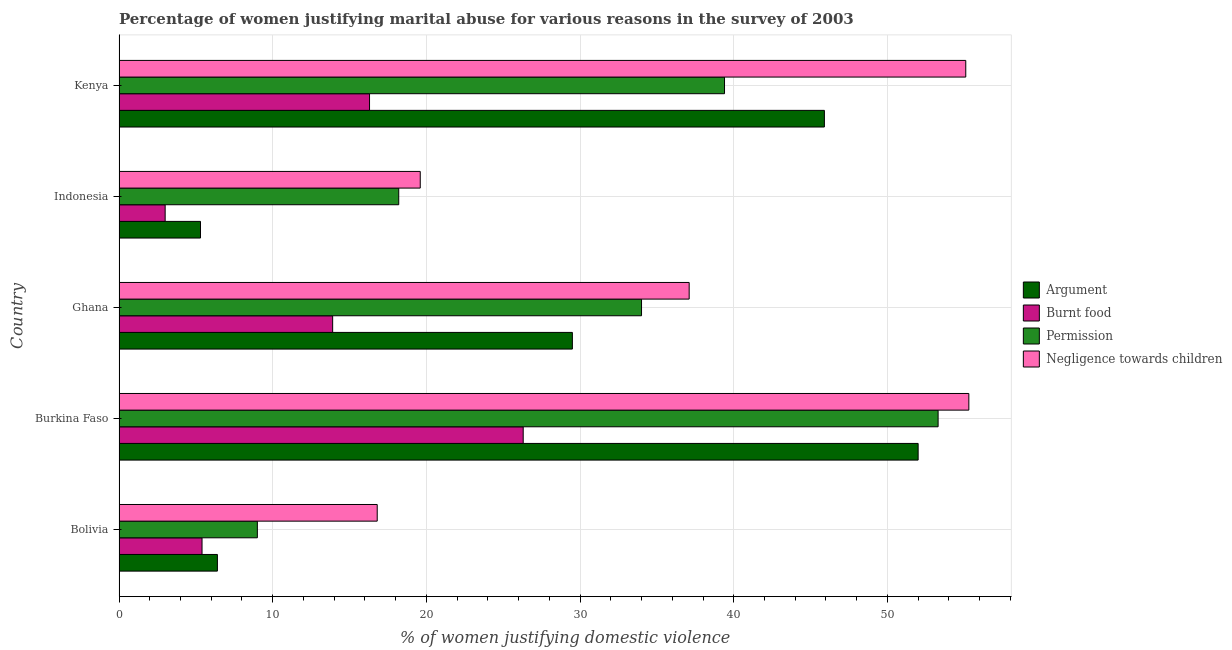How many different coloured bars are there?
Offer a terse response. 4. Are the number of bars on each tick of the Y-axis equal?
Give a very brief answer. Yes. What is the label of the 2nd group of bars from the top?
Offer a terse response. Indonesia. In how many cases, is the number of bars for a given country not equal to the number of legend labels?
Provide a short and direct response. 0. Across all countries, what is the maximum percentage of women justifying abuse for showing negligence towards children?
Offer a terse response. 55.3. Across all countries, what is the minimum percentage of women justifying abuse for burning food?
Your answer should be very brief. 3. In which country was the percentage of women justifying abuse for showing negligence towards children maximum?
Your answer should be compact. Burkina Faso. In which country was the percentage of women justifying abuse for burning food minimum?
Keep it short and to the point. Indonesia. What is the total percentage of women justifying abuse for showing negligence towards children in the graph?
Offer a very short reply. 183.9. What is the difference between the percentage of women justifying abuse for showing negligence towards children in Bolivia and the percentage of women justifying abuse in the case of an argument in Burkina Faso?
Offer a very short reply. -35.2. What is the average percentage of women justifying abuse for showing negligence towards children per country?
Your answer should be compact. 36.78. Is the percentage of women justifying abuse in the case of an argument in Burkina Faso less than that in Indonesia?
Your answer should be compact. No. What is the difference between the highest and the lowest percentage of women justifying abuse for showing negligence towards children?
Your answer should be very brief. 38.5. Is the sum of the percentage of women justifying abuse for showing negligence towards children in Burkina Faso and Indonesia greater than the maximum percentage of women justifying abuse in the case of an argument across all countries?
Keep it short and to the point. Yes. Is it the case that in every country, the sum of the percentage of women justifying abuse for going without permission and percentage of women justifying abuse in the case of an argument is greater than the sum of percentage of women justifying abuse for burning food and percentage of women justifying abuse for showing negligence towards children?
Keep it short and to the point. No. What does the 1st bar from the top in Indonesia represents?
Your answer should be very brief. Negligence towards children. What does the 1st bar from the bottom in Burkina Faso represents?
Keep it short and to the point. Argument. Is it the case that in every country, the sum of the percentage of women justifying abuse in the case of an argument and percentage of women justifying abuse for burning food is greater than the percentage of women justifying abuse for going without permission?
Your answer should be very brief. No. How many countries are there in the graph?
Provide a succinct answer. 5. Are the values on the major ticks of X-axis written in scientific E-notation?
Make the answer very short. No. Does the graph contain grids?
Offer a terse response. Yes. Where does the legend appear in the graph?
Offer a very short reply. Center right. How many legend labels are there?
Keep it short and to the point. 4. How are the legend labels stacked?
Offer a very short reply. Vertical. What is the title of the graph?
Offer a very short reply. Percentage of women justifying marital abuse for various reasons in the survey of 2003. What is the label or title of the X-axis?
Your response must be concise. % of women justifying domestic violence. What is the % of women justifying domestic violence of Burnt food in Bolivia?
Your response must be concise. 5.4. What is the % of women justifying domestic violence of Burnt food in Burkina Faso?
Keep it short and to the point. 26.3. What is the % of women justifying domestic violence in Permission in Burkina Faso?
Provide a short and direct response. 53.3. What is the % of women justifying domestic violence in Negligence towards children in Burkina Faso?
Provide a short and direct response. 55.3. What is the % of women justifying domestic violence in Argument in Ghana?
Ensure brevity in your answer.  29.5. What is the % of women justifying domestic violence of Negligence towards children in Ghana?
Your response must be concise. 37.1. What is the % of women justifying domestic violence of Burnt food in Indonesia?
Provide a short and direct response. 3. What is the % of women justifying domestic violence of Negligence towards children in Indonesia?
Offer a very short reply. 19.6. What is the % of women justifying domestic violence in Argument in Kenya?
Your answer should be very brief. 45.9. What is the % of women justifying domestic violence of Burnt food in Kenya?
Make the answer very short. 16.3. What is the % of women justifying domestic violence in Permission in Kenya?
Your answer should be very brief. 39.4. What is the % of women justifying domestic violence in Negligence towards children in Kenya?
Your answer should be very brief. 55.1. Across all countries, what is the maximum % of women justifying domestic violence in Argument?
Your answer should be compact. 52. Across all countries, what is the maximum % of women justifying domestic violence in Burnt food?
Provide a succinct answer. 26.3. Across all countries, what is the maximum % of women justifying domestic violence in Permission?
Your answer should be compact. 53.3. Across all countries, what is the maximum % of women justifying domestic violence in Negligence towards children?
Provide a succinct answer. 55.3. Across all countries, what is the minimum % of women justifying domestic violence in Burnt food?
Your answer should be very brief. 3. What is the total % of women justifying domestic violence in Argument in the graph?
Provide a short and direct response. 139.1. What is the total % of women justifying domestic violence in Burnt food in the graph?
Offer a terse response. 64.9. What is the total % of women justifying domestic violence of Permission in the graph?
Offer a terse response. 153.9. What is the total % of women justifying domestic violence in Negligence towards children in the graph?
Make the answer very short. 183.9. What is the difference between the % of women justifying domestic violence in Argument in Bolivia and that in Burkina Faso?
Your answer should be compact. -45.6. What is the difference between the % of women justifying domestic violence of Burnt food in Bolivia and that in Burkina Faso?
Keep it short and to the point. -20.9. What is the difference between the % of women justifying domestic violence in Permission in Bolivia and that in Burkina Faso?
Make the answer very short. -44.3. What is the difference between the % of women justifying domestic violence of Negligence towards children in Bolivia and that in Burkina Faso?
Offer a very short reply. -38.5. What is the difference between the % of women justifying domestic violence in Argument in Bolivia and that in Ghana?
Make the answer very short. -23.1. What is the difference between the % of women justifying domestic violence of Burnt food in Bolivia and that in Ghana?
Offer a very short reply. -8.5. What is the difference between the % of women justifying domestic violence in Negligence towards children in Bolivia and that in Ghana?
Ensure brevity in your answer.  -20.3. What is the difference between the % of women justifying domestic violence in Argument in Bolivia and that in Indonesia?
Provide a short and direct response. 1.1. What is the difference between the % of women justifying domestic violence in Argument in Bolivia and that in Kenya?
Offer a terse response. -39.5. What is the difference between the % of women justifying domestic violence in Burnt food in Bolivia and that in Kenya?
Your answer should be very brief. -10.9. What is the difference between the % of women justifying domestic violence in Permission in Bolivia and that in Kenya?
Provide a succinct answer. -30.4. What is the difference between the % of women justifying domestic violence of Negligence towards children in Bolivia and that in Kenya?
Give a very brief answer. -38.3. What is the difference between the % of women justifying domestic violence in Argument in Burkina Faso and that in Ghana?
Make the answer very short. 22.5. What is the difference between the % of women justifying domestic violence of Permission in Burkina Faso and that in Ghana?
Your answer should be very brief. 19.3. What is the difference between the % of women justifying domestic violence of Negligence towards children in Burkina Faso and that in Ghana?
Keep it short and to the point. 18.2. What is the difference between the % of women justifying domestic violence of Argument in Burkina Faso and that in Indonesia?
Keep it short and to the point. 46.7. What is the difference between the % of women justifying domestic violence of Burnt food in Burkina Faso and that in Indonesia?
Make the answer very short. 23.3. What is the difference between the % of women justifying domestic violence in Permission in Burkina Faso and that in Indonesia?
Offer a very short reply. 35.1. What is the difference between the % of women justifying domestic violence of Negligence towards children in Burkina Faso and that in Indonesia?
Provide a succinct answer. 35.7. What is the difference between the % of women justifying domestic violence in Burnt food in Burkina Faso and that in Kenya?
Keep it short and to the point. 10. What is the difference between the % of women justifying domestic violence in Negligence towards children in Burkina Faso and that in Kenya?
Give a very brief answer. 0.2. What is the difference between the % of women justifying domestic violence of Argument in Ghana and that in Indonesia?
Your answer should be very brief. 24.2. What is the difference between the % of women justifying domestic violence of Burnt food in Ghana and that in Indonesia?
Ensure brevity in your answer.  10.9. What is the difference between the % of women justifying domestic violence in Argument in Ghana and that in Kenya?
Your answer should be compact. -16.4. What is the difference between the % of women justifying domestic violence of Negligence towards children in Ghana and that in Kenya?
Your response must be concise. -18. What is the difference between the % of women justifying domestic violence in Argument in Indonesia and that in Kenya?
Your answer should be compact. -40.6. What is the difference between the % of women justifying domestic violence in Burnt food in Indonesia and that in Kenya?
Ensure brevity in your answer.  -13.3. What is the difference between the % of women justifying domestic violence of Permission in Indonesia and that in Kenya?
Your answer should be very brief. -21.2. What is the difference between the % of women justifying domestic violence in Negligence towards children in Indonesia and that in Kenya?
Provide a short and direct response. -35.5. What is the difference between the % of women justifying domestic violence of Argument in Bolivia and the % of women justifying domestic violence of Burnt food in Burkina Faso?
Your response must be concise. -19.9. What is the difference between the % of women justifying domestic violence in Argument in Bolivia and the % of women justifying domestic violence in Permission in Burkina Faso?
Your answer should be compact. -46.9. What is the difference between the % of women justifying domestic violence in Argument in Bolivia and the % of women justifying domestic violence in Negligence towards children in Burkina Faso?
Offer a very short reply. -48.9. What is the difference between the % of women justifying domestic violence of Burnt food in Bolivia and the % of women justifying domestic violence of Permission in Burkina Faso?
Provide a short and direct response. -47.9. What is the difference between the % of women justifying domestic violence in Burnt food in Bolivia and the % of women justifying domestic violence in Negligence towards children in Burkina Faso?
Make the answer very short. -49.9. What is the difference between the % of women justifying domestic violence in Permission in Bolivia and the % of women justifying domestic violence in Negligence towards children in Burkina Faso?
Your response must be concise. -46.3. What is the difference between the % of women justifying domestic violence of Argument in Bolivia and the % of women justifying domestic violence of Permission in Ghana?
Give a very brief answer. -27.6. What is the difference between the % of women justifying domestic violence in Argument in Bolivia and the % of women justifying domestic violence in Negligence towards children in Ghana?
Offer a terse response. -30.7. What is the difference between the % of women justifying domestic violence in Burnt food in Bolivia and the % of women justifying domestic violence in Permission in Ghana?
Your response must be concise. -28.6. What is the difference between the % of women justifying domestic violence in Burnt food in Bolivia and the % of women justifying domestic violence in Negligence towards children in Ghana?
Offer a very short reply. -31.7. What is the difference between the % of women justifying domestic violence in Permission in Bolivia and the % of women justifying domestic violence in Negligence towards children in Ghana?
Offer a very short reply. -28.1. What is the difference between the % of women justifying domestic violence of Argument in Bolivia and the % of women justifying domestic violence of Negligence towards children in Indonesia?
Your answer should be very brief. -13.2. What is the difference between the % of women justifying domestic violence in Burnt food in Bolivia and the % of women justifying domestic violence in Permission in Indonesia?
Offer a terse response. -12.8. What is the difference between the % of women justifying domestic violence in Burnt food in Bolivia and the % of women justifying domestic violence in Negligence towards children in Indonesia?
Ensure brevity in your answer.  -14.2. What is the difference between the % of women justifying domestic violence of Permission in Bolivia and the % of women justifying domestic violence of Negligence towards children in Indonesia?
Keep it short and to the point. -10.6. What is the difference between the % of women justifying domestic violence in Argument in Bolivia and the % of women justifying domestic violence in Burnt food in Kenya?
Your response must be concise. -9.9. What is the difference between the % of women justifying domestic violence of Argument in Bolivia and the % of women justifying domestic violence of Permission in Kenya?
Give a very brief answer. -33. What is the difference between the % of women justifying domestic violence in Argument in Bolivia and the % of women justifying domestic violence in Negligence towards children in Kenya?
Offer a terse response. -48.7. What is the difference between the % of women justifying domestic violence in Burnt food in Bolivia and the % of women justifying domestic violence in Permission in Kenya?
Keep it short and to the point. -34. What is the difference between the % of women justifying domestic violence in Burnt food in Bolivia and the % of women justifying domestic violence in Negligence towards children in Kenya?
Provide a short and direct response. -49.7. What is the difference between the % of women justifying domestic violence in Permission in Bolivia and the % of women justifying domestic violence in Negligence towards children in Kenya?
Offer a terse response. -46.1. What is the difference between the % of women justifying domestic violence in Argument in Burkina Faso and the % of women justifying domestic violence in Burnt food in Ghana?
Give a very brief answer. 38.1. What is the difference between the % of women justifying domestic violence of Argument in Burkina Faso and the % of women justifying domestic violence of Negligence towards children in Ghana?
Offer a very short reply. 14.9. What is the difference between the % of women justifying domestic violence in Burnt food in Burkina Faso and the % of women justifying domestic violence in Permission in Ghana?
Your response must be concise. -7.7. What is the difference between the % of women justifying domestic violence of Permission in Burkina Faso and the % of women justifying domestic violence of Negligence towards children in Ghana?
Keep it short and to the point. 16.2. What is the difference between the % of women justifying domestic violence of Argument in Burkina Faso and the % of women justifying domestic violence of Burnt food in Indonesia?
Provide a short and direct response. 49. What is the difference between the % of women justifying domestic violence in Argument in Burkina Faso and the % of women justifying domestic violence in Permission in Indonesia?
Offer a terse response. 33.8. What is the difference between the % of women justifying domestic violence of Argument in Burkina Faso and the % of women justifying domestic violence of Negligence towards children in Indonesia?
Offer a very short reply. 32.4. What is the difference between the % of women justifying domestic violence in Burnt food in Burkina Faso and the % of women justifying domestic violence in Negligence towards children in Indonesia?
Offer a terse response. 6.7. What is the difference between the % of women justifying domestic violence of Permission in Burkina Faso and the % of women justifying domestic violence of Negligence towards children in Indonesia?
Offer a terse response. 33.7. What is the difference between the % of women justifying domestic violence of Argument in Burkina Faso and the % of women justifying domestic violence of Burnt food in Kenya?
Provide a succinct answer. 35.7. What is the difference between the % of women justifying domestic violence in Argument in Burkina Faso and the % of women justifying domestic violence in Permission in Kenya?
Give a very brief answer. 12.6. What is the difference between the % of women justifying domestic violence of Burnt food in Burkina Faso and the % of women justifying domestic violence of Permission in Kenya?
Provide a succinct answer. -13.1. What is the difference between the % of women justifying domestic violence in Burnt food in Burkina Faso and the % of women justifying domestic violence in Negligence towards children in Kenya?
Ensure brevity in your answer.  -28.8. What is the difference between the % of women justifying domestic violence in Permission in Burkina Faso and the % of women justifying domestic violence in Negligence towards children in Kenya?
Ensure brevity in your answer.  -1.8. What is the difference between the % of women justifying domestic violence in Argument in Ghana and the % of women justifying domestic violence in Burnt food in Indonesia?
Your response must be concise. 26.5. What is the difference between the % of women justifying domestic violence in Argument in Ghana and the % of women justifying domestic violence in Permission in Indonesia?
Offer a very short reply. 11.3. What is the difference between the % of women justifying domestic violence in Burnt food in Ghana and the % of women justifying domestic violence in Permission in Indonesia?
Ensure brevity in your answer.  -4.3. What is the difference between the % of women justifying domestic violence of Burnt food in Ghana and the % of women justifying domestic violence of Negligence towards children in Indonesia?
Offer a very short reply. -5.7. What is the difference between the % of women justifying domestic violence in Argument in Ghana and the % of women justifying domestic violence in Burnt food in Kenya?
Keep it short and to the point. 13.2. What is the difference between the % of women justifying domestic violence in Argument in Ghana and the % of women justifying domestic violence in Negligence towards children in Kenya?
Make the answer very short. -25.6. What is the difference between the % of women justifying domestic violence of Burnt food in Ghana and the % of women justifying domestic violence of Permission in Kenya?
Give a very brief answer. -25.5. What is the difference between the % of women justifying domestic violence of Burnt food in Ghana and the % of women justifying domestic violence of Negligence towards children in Kenya?
Give a very brief answer. -41.2. What is the difference between the % of women justifying domestic violence of Permission in Ghana and the % of women justifying domestic violence of Negligence towards children in Kenya?
Your answer should be compact. -21.1. What is the difference between the % of women justifying domestic violence of Argument in Indonesia and the % of women justifying domestic violence of Permission in Kenya?
Your answer should be compact. -34.1. What is the difference between the % of women justifying domestic violence of Argument in Indonesia and the % of women justifying domestic violence of Negligence towards children in Kenya?
Offer a terse response. -49.8. What is the difference between the % of women justifying domestic violence of Burnt food in Indonesia and the % of women justifying domestic violence of Permission in Kenya?
Make the answer very short. -36.4. What is the difference between the % of women justifying domestic violence of Burnt food in Indonesia and the % of women justifying domestic violence of Negligence towards children in Kenya?
Offer a very short reply. -52.1. What is the difference between the % of women justifying domestic violence of Permission in Indonesia and the % of women justifying domestic violence of Negligence towards children in Kenya?
Provide a succinct answer. -36.9. What is the average % of women justifying domestic violence in Argument per country?
Your response must be concise. 27.82. What is the average % of women justifying domestic violence of Burnt food per country?
Make the answer very short. 12.98. What is the average % of women justifying domestic violence of Permission per country?
Ensure brevity in your answer.  30.78. What is the average % of women justifying domestic violence in Negligence towards children per country?
Offer a very short reply. 36.78. What is the difference between the % of women justifying domestic violence in Argument and % of women justifying domestic violence in Burnt food in Bolivia?
Your answer should be very brief. 1. What is the difference between the % of women justifying domestic violence in Argument and % of women justifying domestic violence in Permission in Bolivia?
Offer a very short reply. -2.6. What is the difference between the % of women justifying domestic violence of Argument and % of women justifying domestic violence of Negligence towards children in Bolivia?
Make the answer very short. -10.4. What is the difference between the % of women justifying domestic violence in Burnt food and % of women justifying domestic violence in Negligence towards children in Bolivia?
Provide a short and direct response. -11.4. What is the difference between the % of women justifying domestic violence of Argument and % of women justifying domestic violence of Burnt food in Burkina Faso?
Your answer should be compact. 25.7. What is the difference between the % of women justifying domestic violence of Burnt food and % of women justifying domestic violence of Permission in Burkina Faso?
Your answer should be compact. -27. What is the difference between the % of women justifying domestic violence in Argument and % of women justifying domestic violence in Permission in Ghana?
Your answer should be very brief. -4.5. What is the difference between the % of women justifying domestic violence of Burnt food and % of women justifying domestic violence of Permission in Ghana?
Ensure brevity in your answer.  -20.1. What is the difference between the % of women justifying domestic violence in Burnt food and % of women justifying domestic violence in Negligence towards children in Ghana?
Your answer should be very brief. -23.2. What is the difference between the % of women justifying domestic violence of Argument and % of women justifying domestic violence of Permission in Indonesia?
Provide a succinct answer. -12.9. What is the difference between the % of women justifying domestic violence in Argument and % of women justifying domestic violence in Negligence towards children in Indonesia?
Provide a short and direct response. -14.3. What is the difference between the % of women justifying domestic violence in Burnt food and % of women justifying domestic violence in Permission in Indonesia?
Offer a terse response. -15.2. What is the difference between the % of women justifying domestic violence in Burnt food and % of women justifying domestic violence in Negligence towards children in Indonesia?
Your response must be concise. -16.6. What is the difference between the % of women justifying domestic violence in Argument and % of women justifying domestic violence in Burnt food in Kenya?
Provide a succinct answer. 29.6. What is the difference between the % of women justifying domestic violence of Argument and % of women justifying domestic violence of Negligence towards children in Kenya?
Make the answer very short. -9.2. What is the difference between the % of women justifying domestic violence in Burnt food and % of women justifying domestic violence in Permission in Kenya?
Give a very brief answer. -23.1. What is the difference between the % of women justifying domestic violence in Burnt food and % of women justifying domestic violence in Negligence towards children in Kenya?
Give a very brief answer. -38.8. What is the difference between the % of women justifying domestic violence of Permission and % of women justifying domestic violence of Negligence towards children in Kenya?
Your answer should be compact. -15.7. What is the ratio of the % of women justifying domestic violence of Argument in Bolivia to that in Burkina Faso?
Give a very brief answer. 0.12. What is the ratio of the % of women justifying domestic violence of Burnt food in Bolivia to that in Burkina Faso?
Keep it short and to the point. 0.21. What is the ratio of the % of women justifying domestic violence in Permission in Bolivia to that in Burkina Faso?
Keep it short and to the point. 0.17. What is the ratio of the % of women justifying domestic violence of Negligence towards children in Bolivia to that in Burkina Faso?
Your response must be concise. 0.3. What is the ratio of the % of women justifying domestic violence in Argument in Bolivia to that in Ghana?
Provide a short and direct response. 0.22. What is the ratio of the % of women justifying domestic violence of Burnt food in Bolivia to that in Ghana?
Provide a short and direct response. 0.39. What is the ratio of the % of women justifying domestic violence in Permission in Bolivia to that in Ghana?
Provide a succinct answer. 0.26. What is the ratio of the % of women justifying domestic violence of Negligence towards children in Bolivia to that in Ghana?
Offer a very short reply. 0.45. What is the ratio of the % of women justifying domestic violence in Argument in Bolivia to that in Indonesia?
Keep it short and to the point. 1.21. What is the ratio of the % of women justifying domestic violence of Burnt food in Bolivia to that in Indonesia?
Offer a very short reply. 1.8. What is the ratio of the % of women justifying domestic violence in Permission in Bolivia to that in Indonesia?
Give a very brief answer. 0.49. What is the ratio of the % of women justifying domestic violence of Argument in Bolivia to that in Kenya?
Offer a terse response. 0.14. What is the ratio of the % of women justifying domestic violence in Burnt food in Bolivia to that in Kenya?
Offer a terse response. 0.33. What is the ratio of the % of women justifying domestic violence of Permission in Bolivia to that in Kenya?
Keep it short and to the point. 0.23. What is the ratio of the % of women justifying domestic violence of Negligence towards children in Bolivia to that in Kenya?
Provide a succinct answer. 0.3. What is the ratio of the % of women justifying domestic violence in Argument in Burkina Faso to that in Ghana?
Your response must be concise. 1.76. What is the ratio of the % of women justifying domestic violence of Burnt food in Burkina Faso to that in Ghana?
Your answer should be compact. 1.89. What is the ratio of the % of women justifying domestic violence in Permission in Burkina Faso to that in Ghana?
Keep it short and to the point. 1.57. What is the ratio of the % of women justifying domestic violence in Negligence towards children in Burkina Faso to that in Ghana?
Keep it short and to the point. 1.49. What is the ratio of the % of women justifying domestic violence of Argument in Burkina Faso to that in Indonesia?
Provide a short and direct response. 9.81. What is the ratio of the % of women justifying domestic violence of Burnt food in Burkina Faso to that in Indonesia?
Make the answer very short. 8.77. What is the ratio of the % of women justifying domestic violence of Permission in Burkina Faso to that in Indonesia?
Offer a terse response. 2.93. What is the ratio of the % of women justifying domestic violence of Negligence towards children in Burkina Faso to that in Indonesia?
Offer a terse response. 2.82. What is the ratio of the % of women justifying domestic violence of Argument in Burkina Faso to that in Kenya?
Keep it short and to the point. 1.13. What is the ratio of the % of women justifying domestic violence of Burnt food in Burkina Faso to that in Kenya?
Keep it short and to the point. 1.61. What is the ratio of the % of women justifying domestic violence in Permission in Burkina Faso to that in Kenya?
Ensure brevity in your answer.  1.35. What is the ratio of the % of women justifying domestic violence of Negligence towards children in Burkina Faso to that in Kenya?
Offer a very short reply. 1. What is the ratio of the % of women justifying domestic violence of Argument in Ghana to that in Indonesia?
Offer a very short reply. 5.57. What is the ratio of the % of women justifying domestic violence of Burnt food in Ghana to that in Indonesia?
Keep it short and to the point. 4.63. What is the ratio of the % of women justifying domestic violence in Permission in Ghana to that in Indonesia?
Provide a succinct answer. 1.87. What is the ratio of the % of women justifying domestic violence of Negligence towards children in Ghana to that in Indonesia?
Ensure brevity in your answer.  1.89. What is the ratio of the % of women justifying domestic violence in Argument in Ghana to that in Kenya?
Your answer should be very brief. 0.64. What is the ratio of the % of women justifying domestic violence of Burnt food in Ghana to that in Kenya?
Ensure brevity in your answer.  0.85. What is the ratio of the % of women justifying domestic violence in Permission in Ghana to that in Kenya?
Offer a very short reply. 0.86. What is the ratio of the % of women justifying domestic violence of Negligence towards children in Ghana to that in Kenya?
Your response must be concise. 0.67. What is the ratio of the % of women justifying domestic violence of Argument in Indonesia to that in Kenya?
Make the answer very short. 0.12. What is the ratio of the % of women justifying domestic violence of Burnt food in Indonesia to that in Kenya?
Offer a terse response. 0.18. What is the ratio of the % of women justifying domestic violence of Permission in Indonesia to that in Kenya?
Make the answer very short. 0.46. What is the ratio of the % of women justifying domestic violence of Negligence towards children in Indonesia to that in Kenya?
Offer a terse response. 0.36. What is the difference between the highest and the second highest % of women justifying domestic violence of Permission?
Your response must be concise. 13.9. What is the difference between the highest and the second highest % of women justifying domestic violence in Negligence towards children?
Your answer should be compact. 0.2. What is the difference between the highest and the lowest % of women justifying domestic violence of Argument?
Make the answer very short. 46.7. What is the difference between the highest and the lowest % of women justifying domestic violence in Burnt food?
Offer a very short reply. 23.3. What is the difference between the highest and the lowest % of women justifying domestic violence in Permission?
Make the answer very short. 44.3. What is the difference between the highest and the lowest % of women justifying domestic violence in Negligence towards children?
Ensure brevity in your answer.  38.5. 